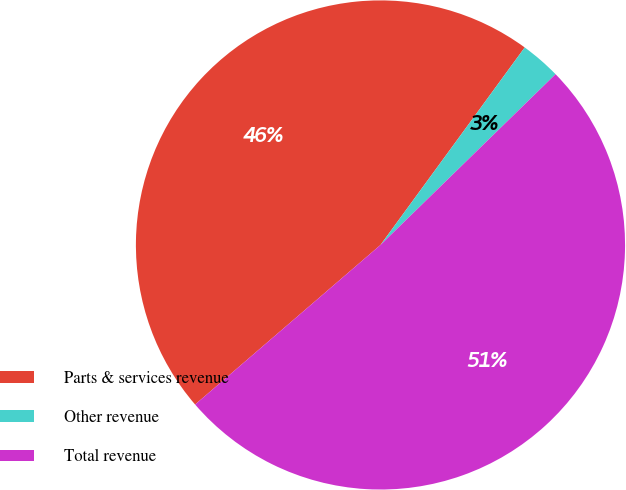<chart> <loc_0><loc_0><loc_500><loc_500><pie_chart><fcel>Parts & services revenue<fcel>Other revenue<fcel>Total revenue<nl><fcel>46.35%<fcel>2.66%<fcel>50.99%<nl></chart> 